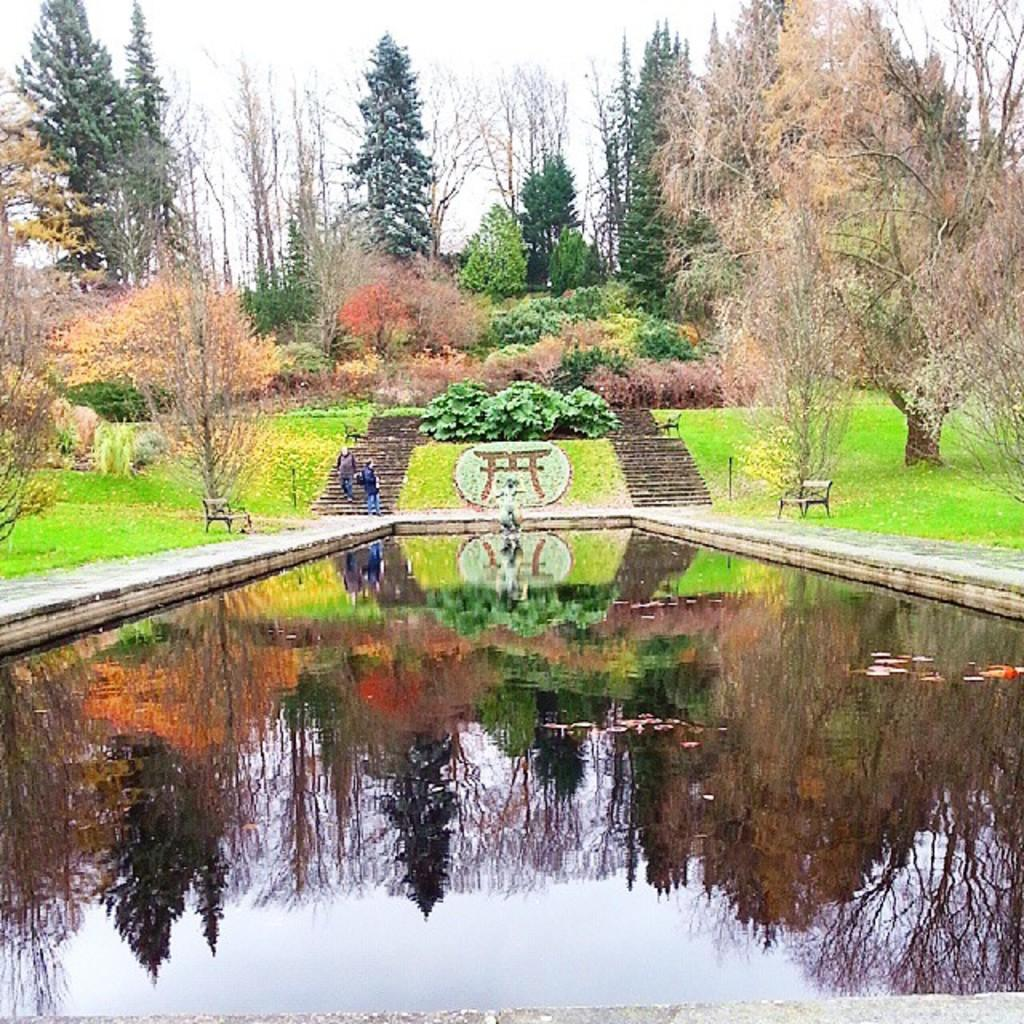What type of body of water is present in the image? There is a pond in the image. How many people are in the image? There are two people in the image. What type of seating is visible in the image? There are two chairs in the image. What type of vegetation is present in the image? There are trees and plants in the image. What is visible at the top of the image? The sky is visible at the top of the image. What type of force is being applied to the patch in the image? There is no patch present in the image, so no force can be applied to it. 